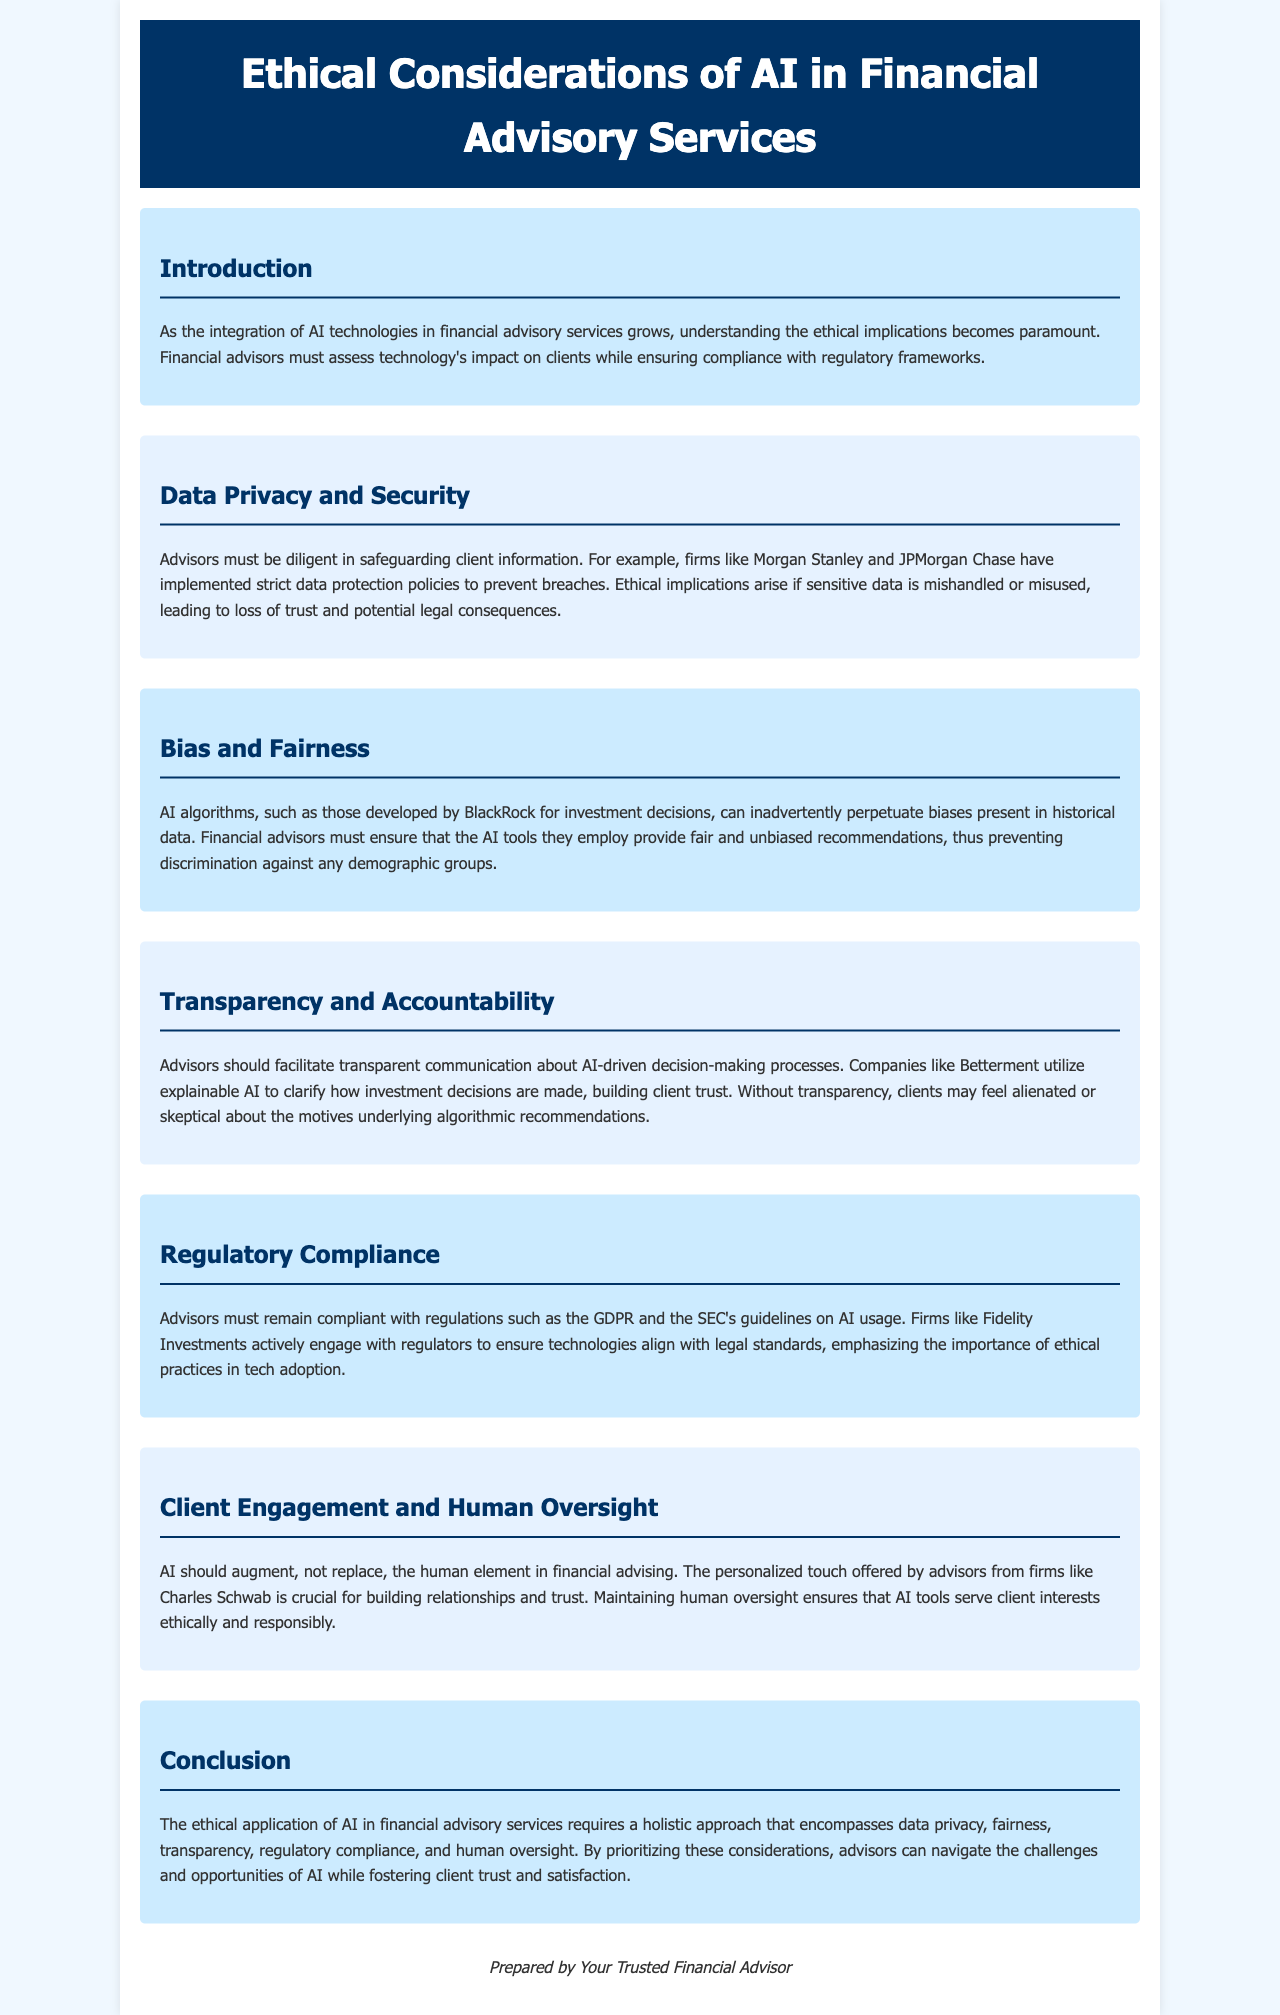What is the main focus of the brochure? The brochure emphasizes the ethical implications of AI in financial advisory services.
Answer: ethical implications of AI in financial advisory services Which company is mentioned as having strict data protection policies? Morgan Stanley is cited as implementing strict data protection policies to safeguard client information.
Answer: Morgan Stanley What algorithm-related issue is highlighted in the section about Bias and Fairness? The section discusses the potential for AI algorithms to perpetuate biases present in historical data.
Answer: perpetuate biases What does Betterment utilize to clarify decision-making processes? Betterment employs explainable AI to promote transparency in investment decisions.
Answer: explainable AI Which regulatory frameworks must financial advisors comply with? Advisors must remain compliant with regulations such as the GDPR and the SEC's guidelines.
Answer: GDPR and the SEC How should AI tools be utilized according to the brochure? AI should augment, not replace, the human element in financial advising.
Answer: augment, not replace What is a key topic in the conclusion of the brochure? The conclusion stresses the need for a holistic approach to ethical AI application in advisory services.
Answer: holistic approach Which company is mentioned as engaging with regulators for tech compliance? Fidelity Investments actively engages with regulators to ensure compliance with legal standards.
Answer: Fidelity Investments 